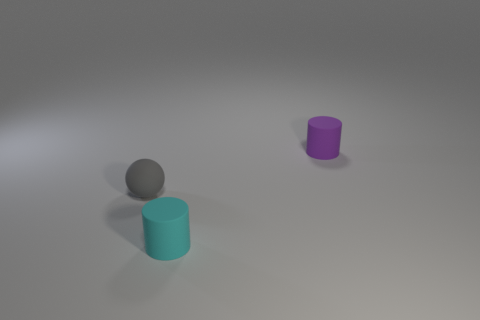The small cylinder behind the cylinder that is in front of the purple rubber object is what color?
Ensure brevity in your answer.  Purple. What is the material of the purple thing that is the same size as the cyan object?
Offer a very short reply. Rubber. How many metallic things are small purple objects or tiny red blocks?
Your answer should be compact. 0. There is a tiny rubber thing that is behind the cyan cylinder and on the left side of the small purple thing; what is its color?
Your answer should be very brief. Gray. What number of tiny purple objects are on the right side of the small purple thing?
Give a very brief answer. 0. What material is the small gray thing?
Give a very brief answer. Rubber. What is the color of the tiny rubber cylinder that is to the right of the small cylinder that is in front of the small object that is right of the cyan rubber cylinder?
Your response must be concise. Purple. What number of cyan rubber cubes are the same size as the purple thing?
Your answer should be very brief. 0. There is a small rubber thing to the left of the cyan rubber cylinder; what is its color?
Your response must be concise. Gray. What number of other objects are there of the same size as the ball?
Ensure brevity in your answer.  2. 